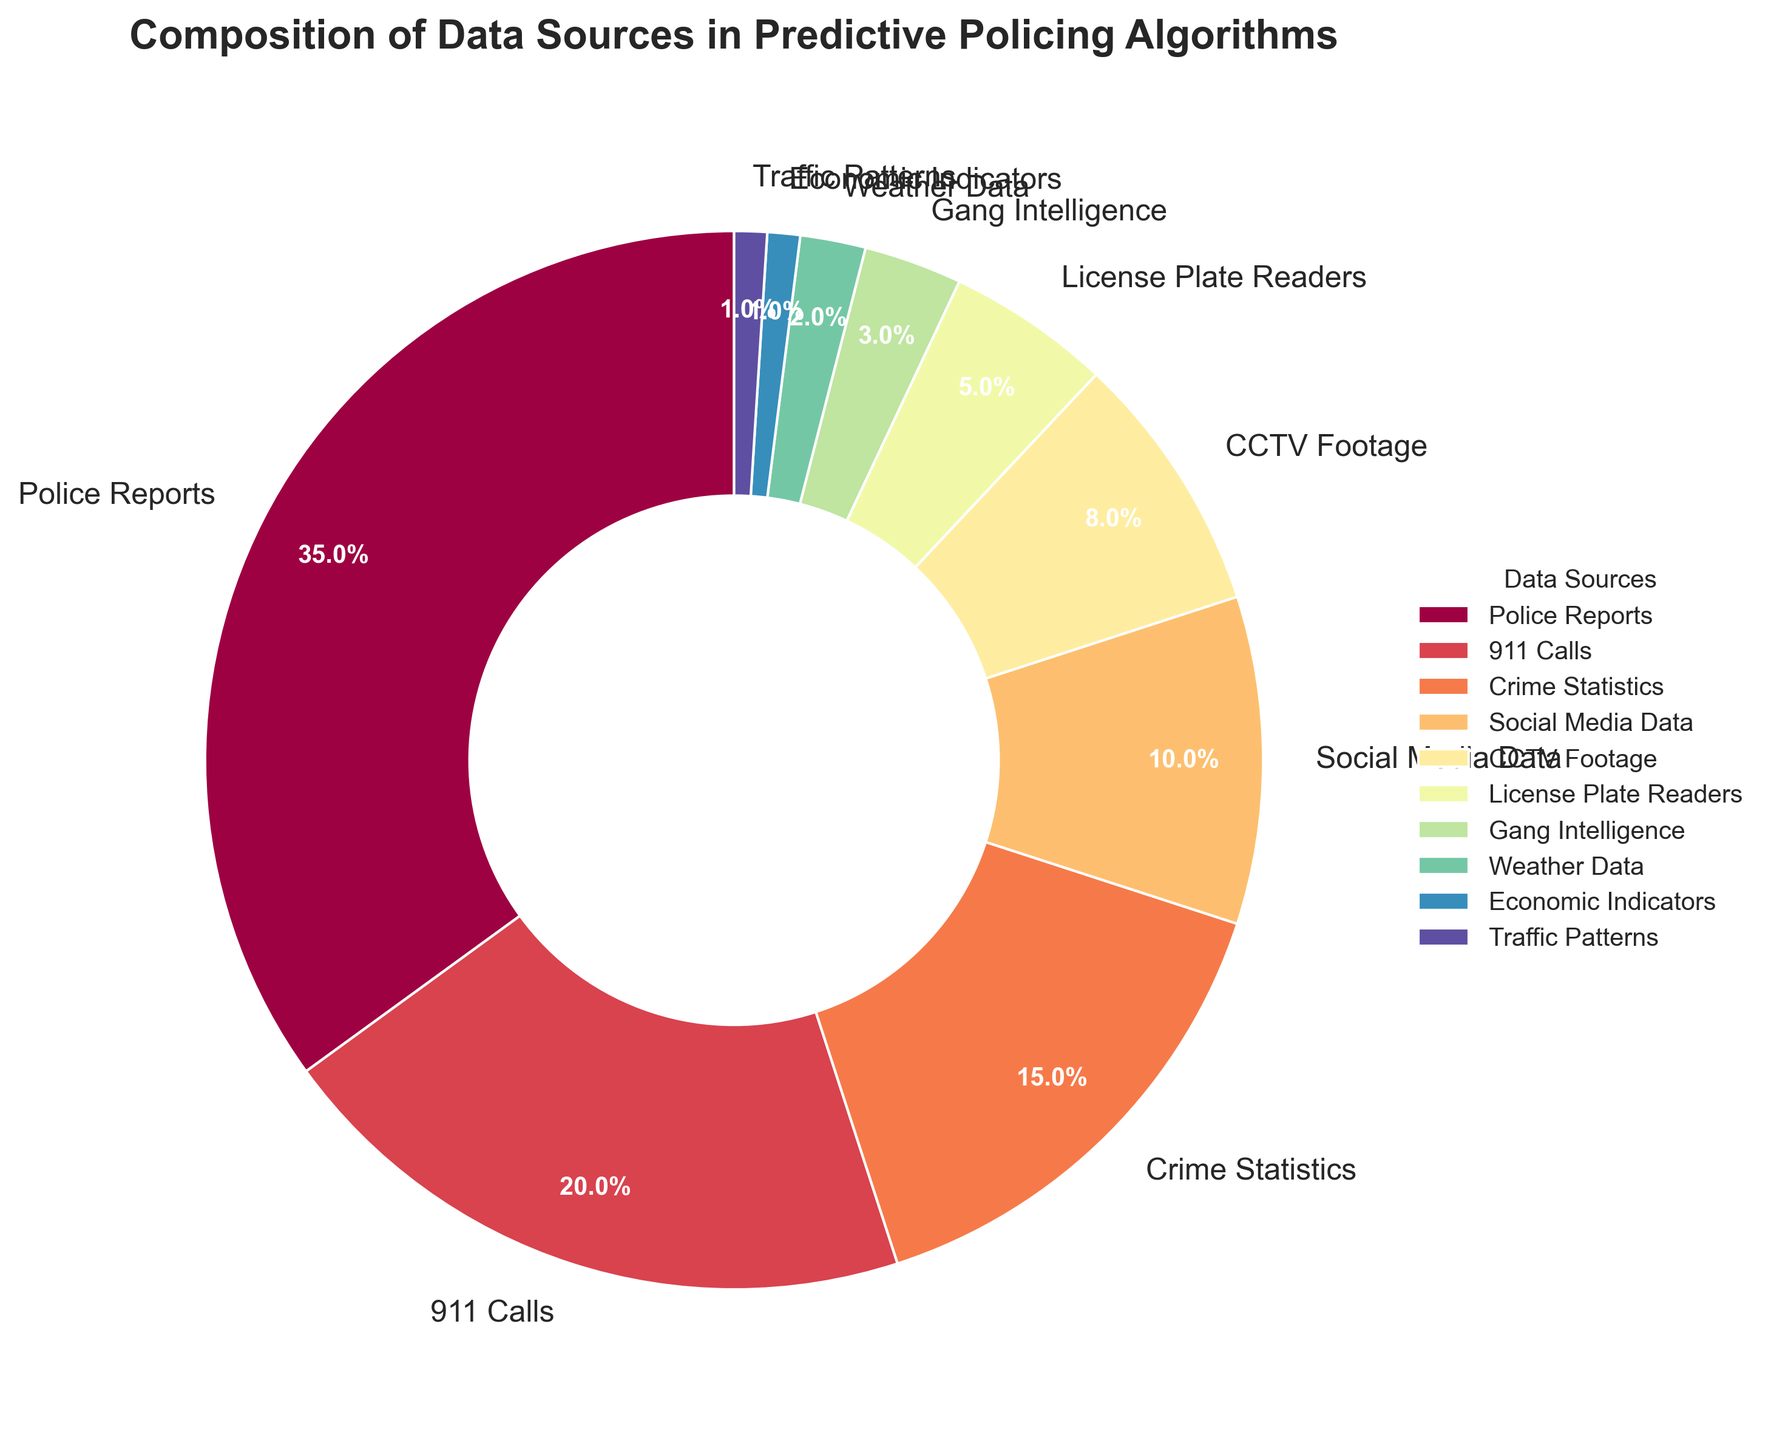What percentage of the data sources are from 'Police Reports' and '911 Calls' combined? To find the combined percentage, add the percentage of 'Police Reports' (35%) and '911 Calls' (20%). 35 + 20 = 55.
Answer: 55% Which data source has the smallest contribution? Identify the category with the lowest percentage, which is 'Traffic Patterns' and 'Economic Indicators' both at 1%.
Answer: Traffic Patterns and Economic Indicators What is the difference in percentage between 'Crime Statistics' and 'Social Media Data'? Subtract the percentage of 'Social Media Data' (10%) from 'Crime Statistics' (15%). 15 - 10 = 5.
Answer: 5% Does 'CCTV Footage' contribute more or less than 'License Plate Readers'? Compare the percentages of 'CCTV Footage' (8%) and 'License Plate Readers' (5%). 8% is greater than 5%.
Answer: More Which data source category has a contribution percentage closest to 10%? Examine the percentages and find 'Social Media Data' at 10%.
Answer: Social Media Data How many categories contribute more than 10% each to the predictive policing algorithms? Identify the categories with percentages over 10%: 'Police Reports' (35%), '911 Calls' (20%), and 'Crime Statistics' (15%). Count these categories, which total 3.
Answer: 3 If you were to combine 'Weather Data', 'Economic Indicators', and 'Traffic Patterns', what would their total contribution be? Add the percentages of 'Weather Data' (2%), 'Economic Indicators' (1%), and 'Traffic Patterns' (1%). 2 + 1 + 1 = 4.
Answer: 4% Which data source category is represented by the largest wedge in the pie chart? The wedge with the largest slice visually represents 'Police Reports' at 35%.
Answer: Police Reports Are there more categories with contributions greater than 5% or less than 5%? Count the categories with percentages greater than 5% (Police Reports, 911 Calls, Crime Statistics, Social Media Data, CCTV Footage - 5 categories) and those with percentages less than 5% (License Plate Readers, Gang Intelligence, Weather Data, Economic Indicators, Traffic Patterns - 5 categories).
Answer: Equal Which category's percentage exactly matches its visual significance in being closer to the center? 'Social Media Data' (10%) is represented with a notable wedge, halfway through the scale but less central than the outer larger ones.
Answer: Social Media Data 